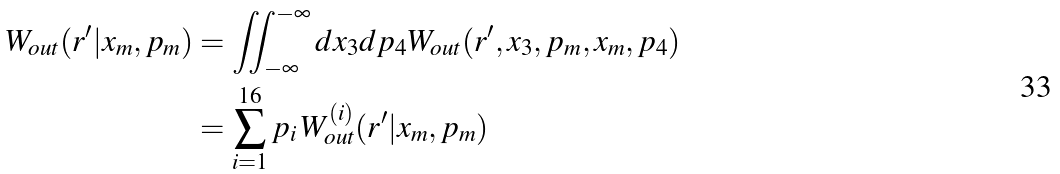Convert formula to latex. <formula><loc_0><loc_0><loc_500><loc_500>W _ { o u t } ( r ^ { \prime } | x _ { m } , p _ { m } ) & = \iint _ { - \infty } ^ { - \infty } d x _ { 3 } d p _ { 4 } W _ { o u t } ( r ^ { \prime } , x _ { 3 } , p _ { m } , x _ { m } , p _ { 4 } ) \\ & = \sum _ { i = 1 } ^ { 1 6 } p _ { i } \, W ^ { ( i ) } _ { o u t } ( r ^ { \prime } | x _ { m } , p _ { m } )</formula> 